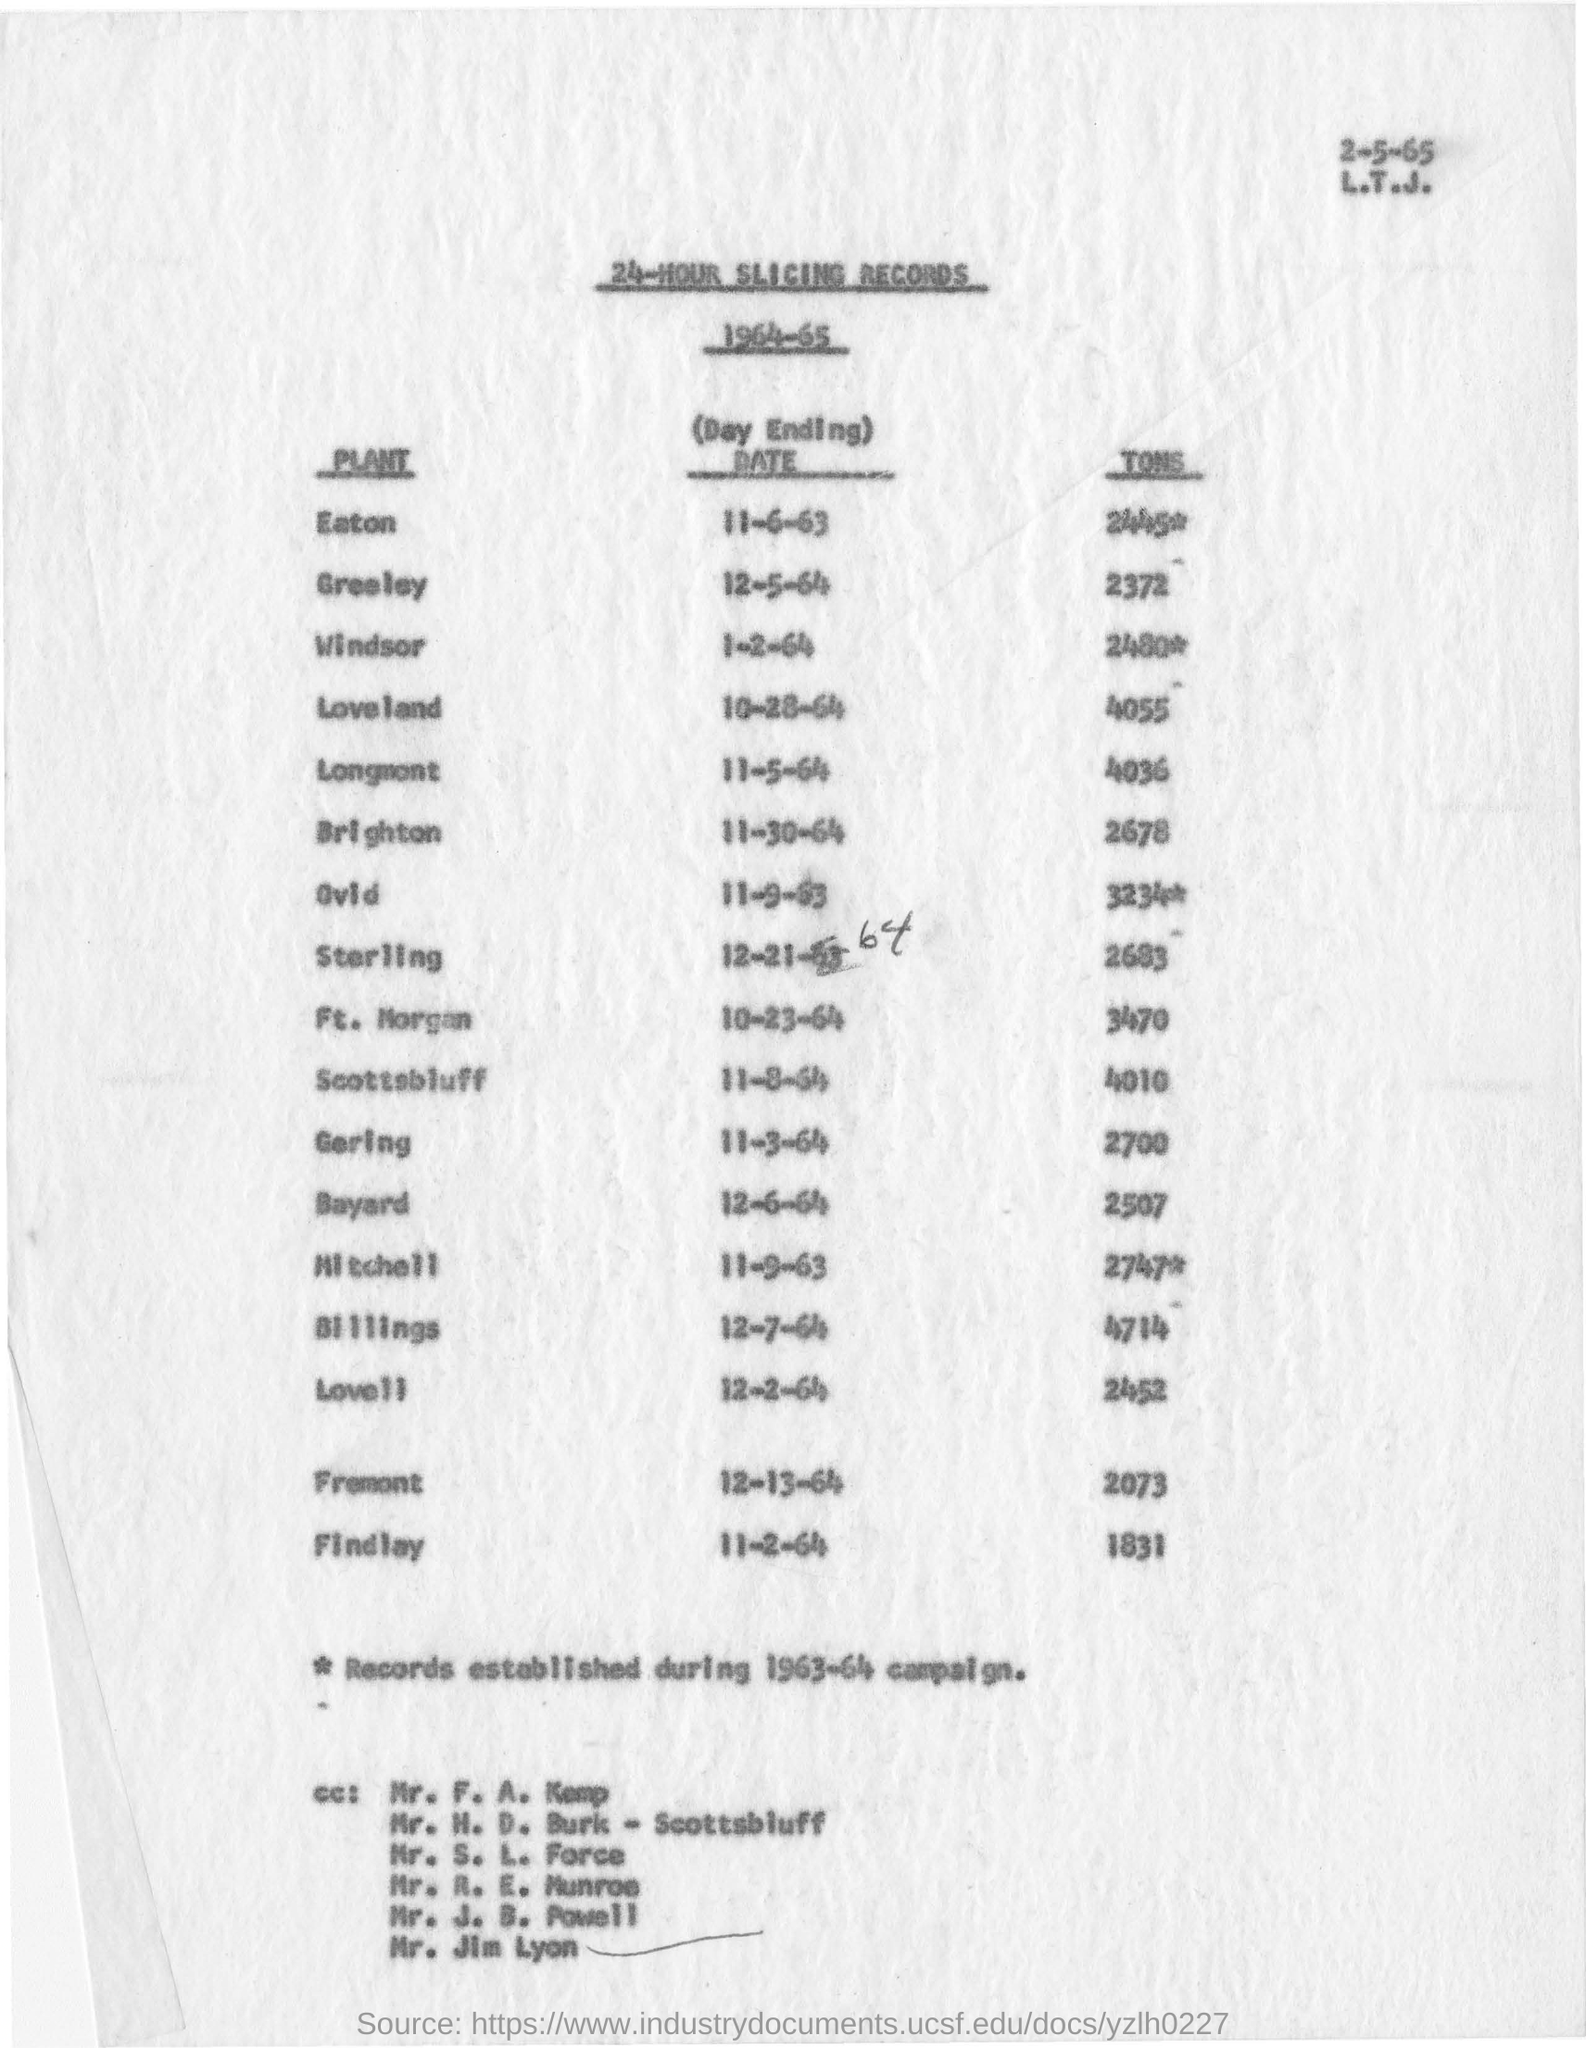What is the document about?
Your response must be concise. 24-HOUR SLICING RECORDS. How many tons are recorded from Ovid plant?
Provide a succinct answer. 3234. Which year are these records collected?
Your response must be concise. 1964-65. How many tons are recorded on 12-7-64?
Provide a succinct answer. 4714. 